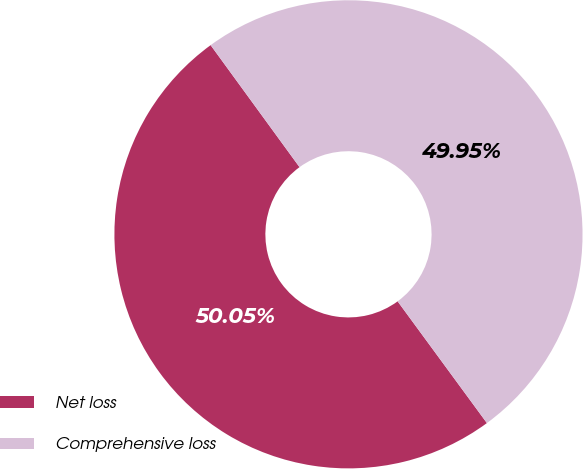Convert chart to OTSL. <chart><loc_0><loc_0><loc_500><loc_500><pie_chart><fcel>Net loss<fcel>Comprehensive loss<nl><fcel>50.05%<fcel>49.95%<nl></chart> 